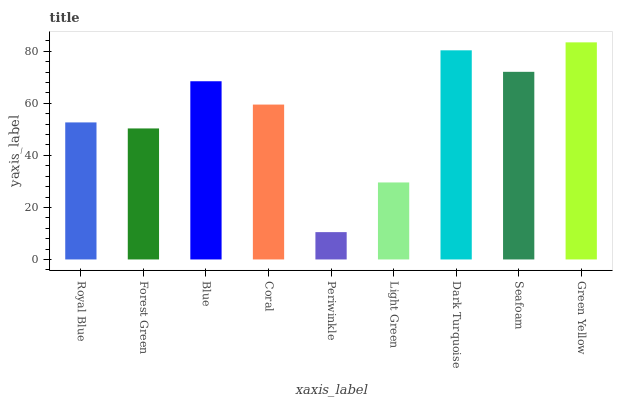Is Periwinkle the minimum?
Answer yes or no. Yes. Is Green Yellow the maximum?
Answer yes or no. Yes. Is Forest Green the minimum?
Answer yes or no. No. Is Forest Green the maximum?
Answer yes or no. No. Is Royal Blue greater than Forest Green?
Answer yes or no. Yes. Is Forest Green less than Royal Blue?
Answer yes or no. Yes. Is Forest Green greater than Royal Blue?
Answer yes or no. No. Is Royal Blue less than Forest Green?
Answer yes or no. No. Is Coral the high median?
Answer yes or no. Yes. Is Coral the low median?
Answer yes or no. Yes. Is Periwinkle the high median?
Answer yes or no. No. Is Royal Blue the low median?
Answer yes or no. No. 